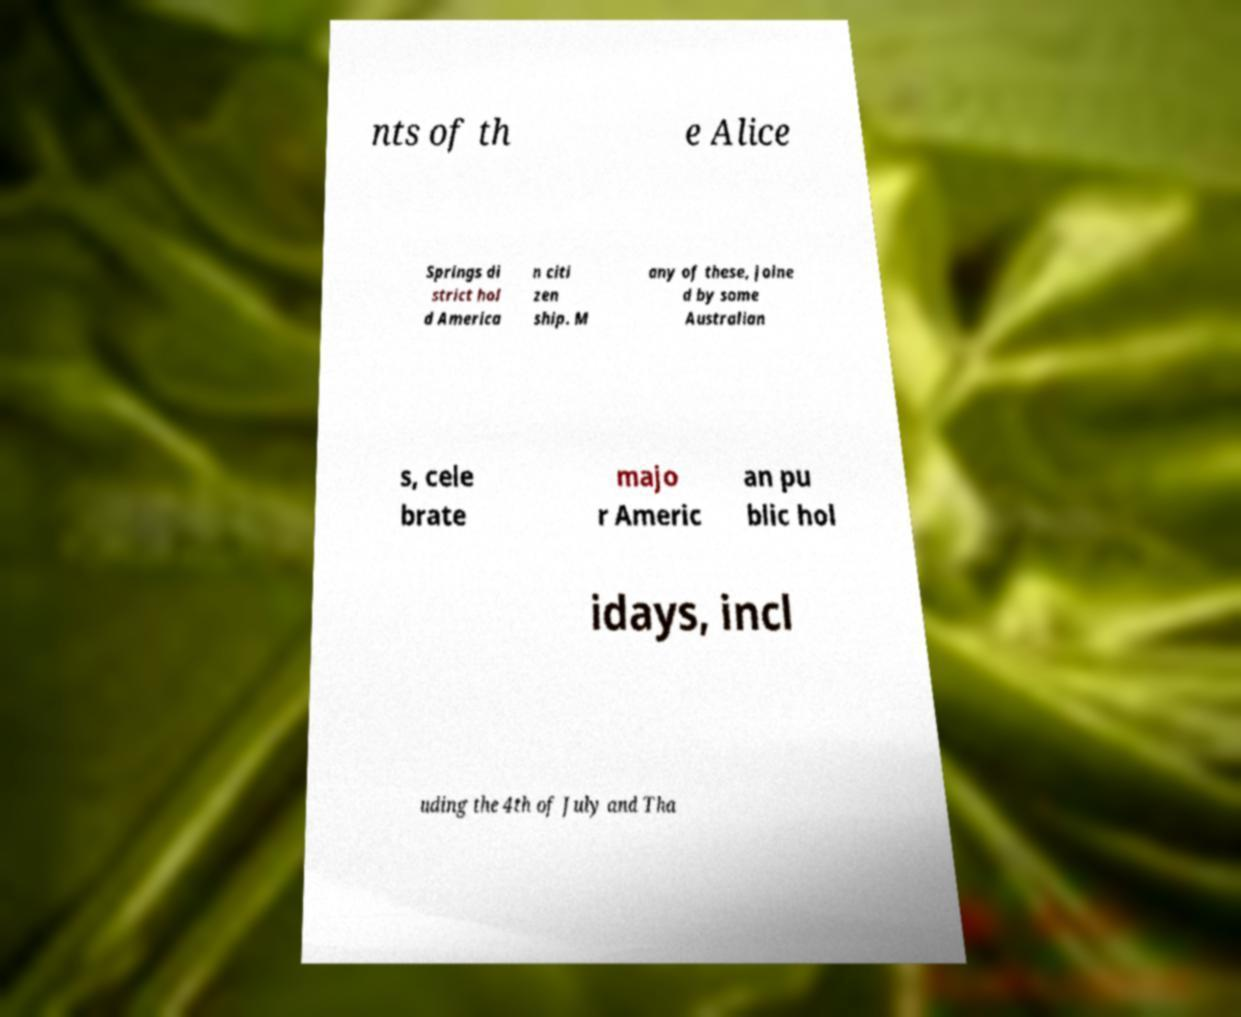For documentation purposes, I need the text within this image transcribed. Could you provide that? nts of th e Alice Springs di strict hol d America n citi zen ship. M any of these, joine d by some Australian s, cele brate majo r Americ an pu blic hol idays, incl uding the 4th of July and Tha 